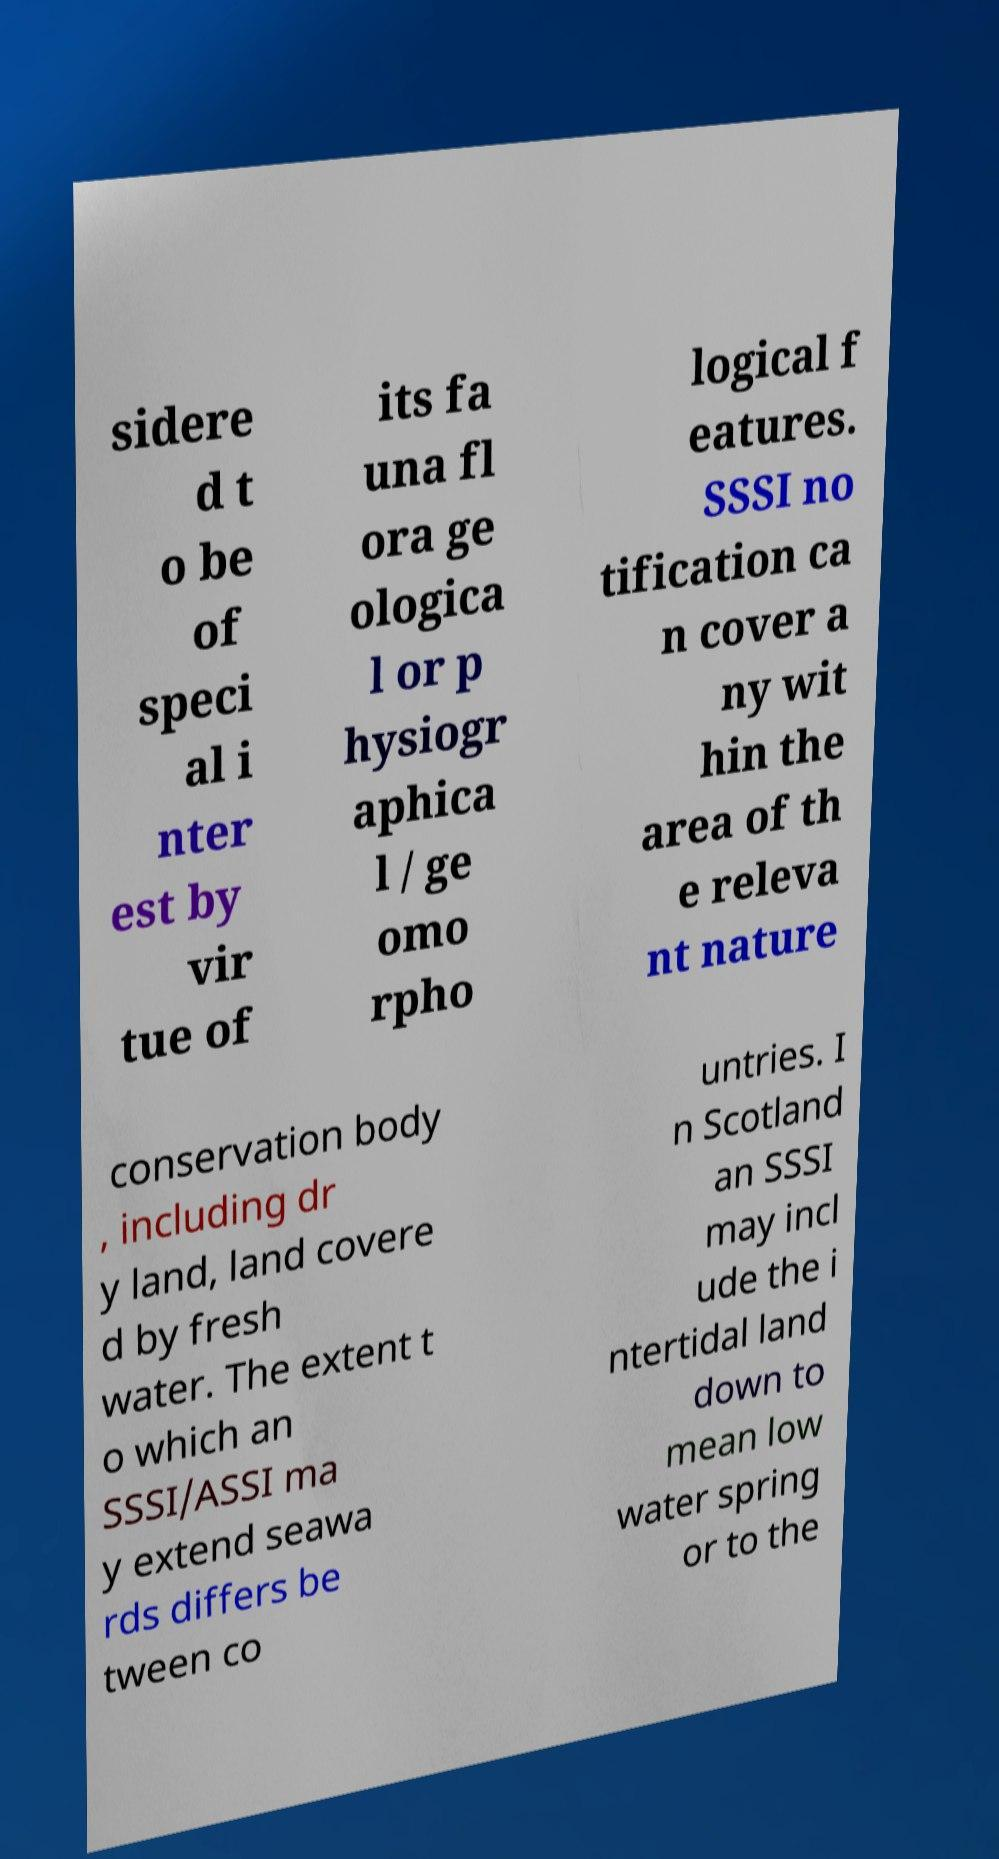Please identify and transcribe the text found in this image. sidere d t o be of speci al i nter est by vir tue of its fa una fl ora ge ologica l or p hysiogr aphica l / ge omo rpho logical f eatures. SSSI no tification ca n cover a ny wit hin the area of th e releva nt nature conservation body , including dr y land, land covere d by fresh water. The extent t o which an SSSI/ASSI ma y extend seawa rds differs be tween co untries. I n Scotland an SSSI may incl ude the i ntertidal land down to mean low water spring or to the 